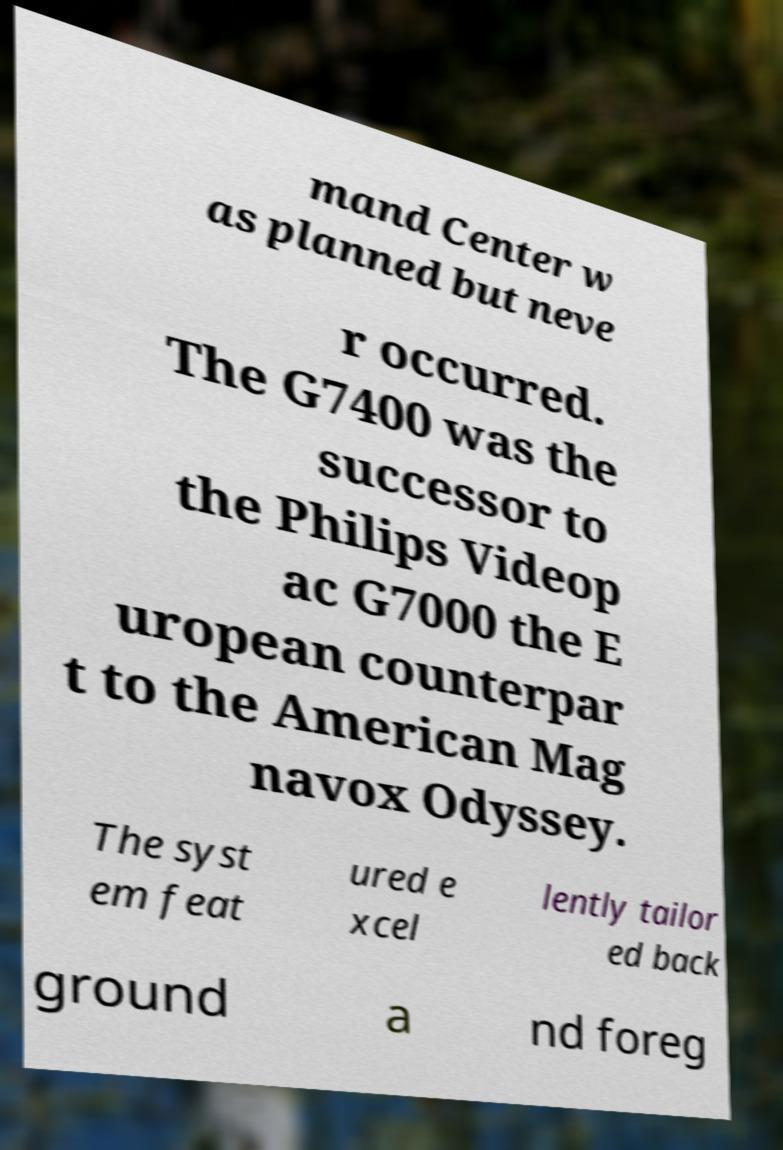Could you assist in decoding the text presented in this image and type it out clearly? mand Center w as planned but neve r occurred. The G7400 was the successor to the Philips Videop ac G7000 the E uropean counterpar t to the American Mag navox Odyssey. The syst em feat ured e xcel lently tailor ed back ground a nd foreg 